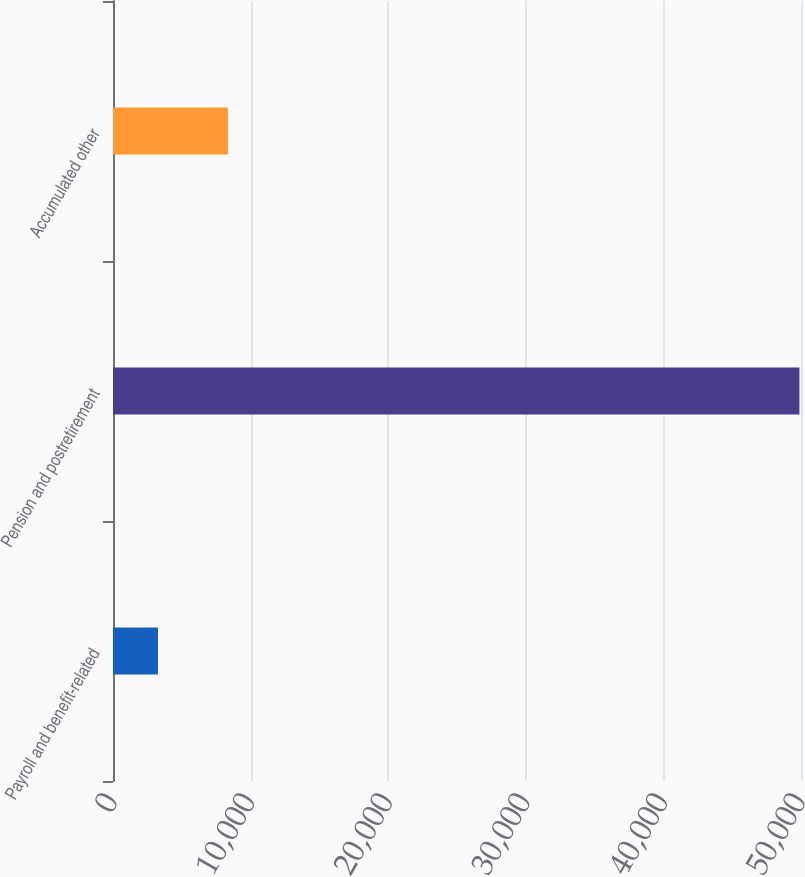Convert chart. <chart><loc_0><loc_0><loc_500><loc_500><bar_chart><fcel>Payroll and benefit-related<fcel>Pension and postretirement<fcel>Accumulated other<nl><fcel>3268<fcel>49886<fcel>8353<nl></chart> 